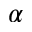Convert formula to latex. <formula><loc_0><loc_0><loc_500><loc_500>\alpha</formula> 